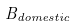<formula> <loc_0><loc_0><loc_500><loc_500>B _ { d o m e s t i c }</formula> 